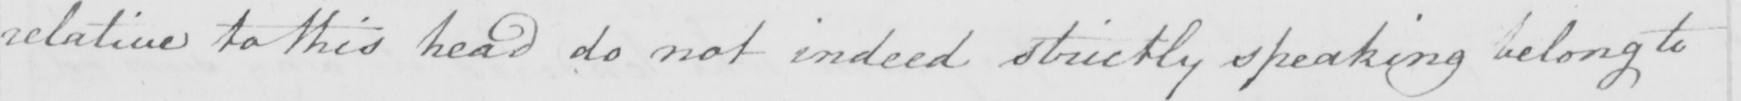What text is written in this handwritten line? relatives to this head do not indeed strictly speaking belong to 